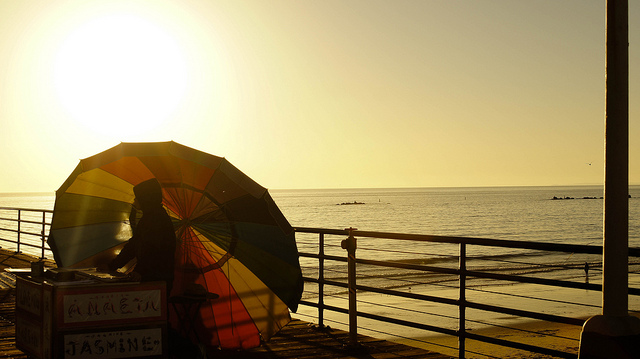What is the man holding? The man in the image is standing behind a cart, with a large, striped umbrella mounted on it, which dominates the scenery. This kind of setup is typical for beachside vendors, offering refreshments or goods. 